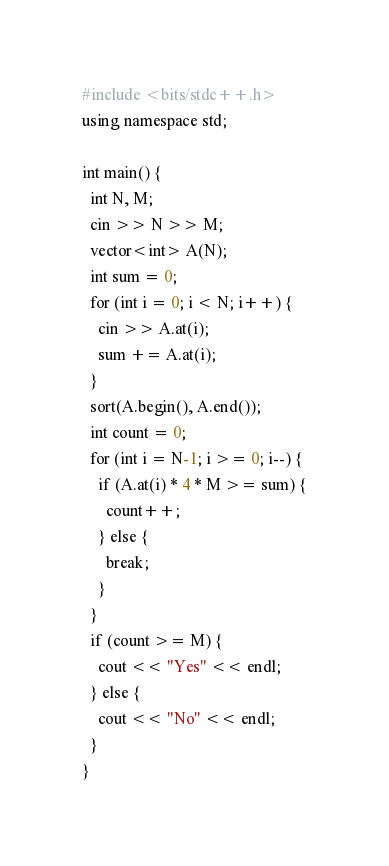Convert code to text. <code><loc_0><loc_0><loc_500><loc_500><_C++_>#include <bits/stdc++.h>
using namespace std;

int main() {
  int N, M;
  cin >> N >> M;
  vector<int> A(N);
  int sum = 0;
  for (int i = 0; i < N; i++) {
    cin >> A.at(i);
    sum += A.at(i);
  }
  sort(A.begin(), A.end());
  int count = 0;
  for (int i = N-1; i >= 0; i--) {
    if (A.at(i) * 4 * M >= sum) {
      count++;
    } else {
      break;
    }
  }
  if (count >= M) {
    cout << "Yes" << endl;
  } else {
    cout << "No" << endl;
  }
}</code> 